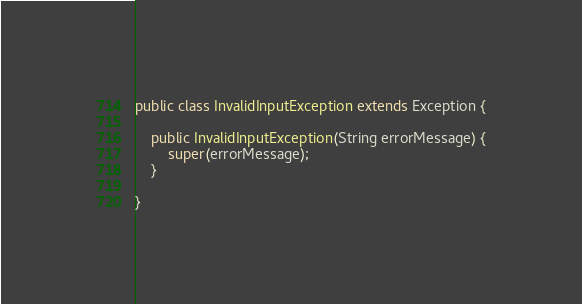<code> <loc_0><loc_0><loc_500><loc_500><_Java_>
public class InvalidInputException extends Exception {
	
	public InvalidInputException(String errorMessage) {
		super(errorMessage);
	}

}
</code> 